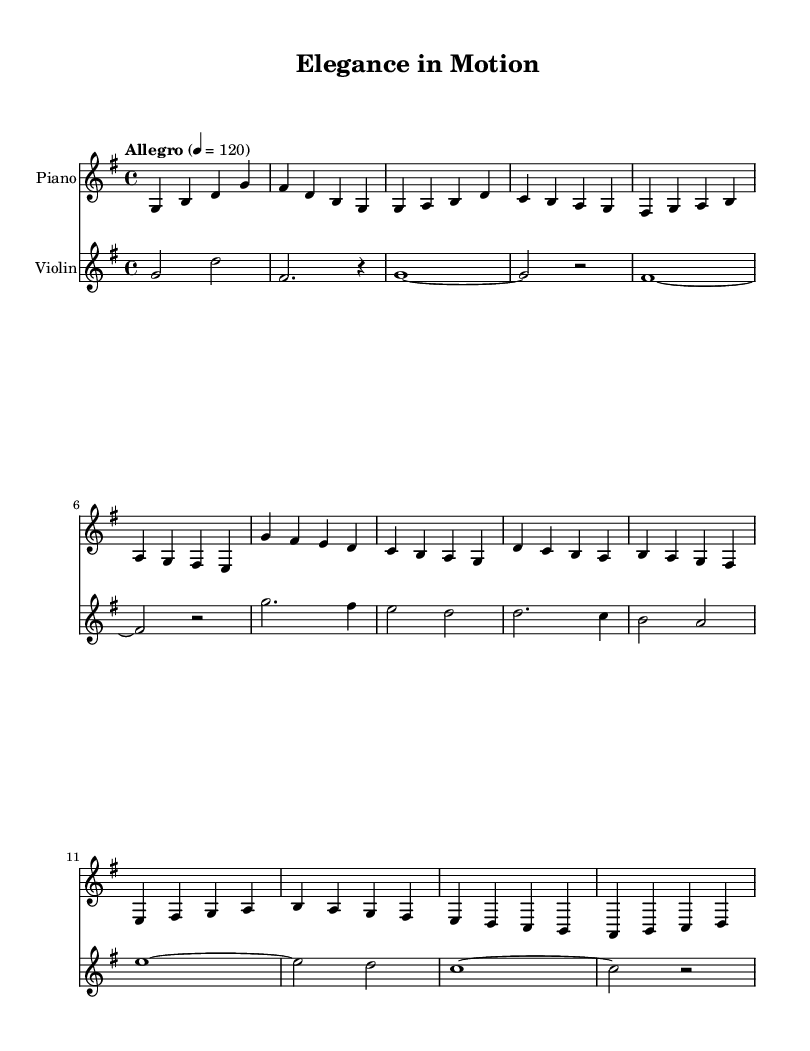What is the key signature of this music? The key signature indicates that this piece is in G major, which is represented by one sharp (F#). The sharp is found in the key signature area at the beginning of the staff.
Answer: G major What is the time signature of this piece? The time signature is shown as 4/4, which means there are four beats in each measure and the quarter note receives one beat. This can be seen at the beginning of the staff, right after the key signature.
Answer: 4/4 What is the tempo marking of this composition? The tempo marking states "Allegro" followed by "4 = 120", which indicates the piece should be played at a lively pace of 120 beats per minute. This is clearly written at the start of the score above the staff.
Answer: Allegro, 120 How many measures are there in the piano part? By counting the horizontal lines that represent measures in the piano staff, there are a total of 12 measures. This count reflects the sections of music combined into the staff.
Answer: 12 Which instrument plays a melody primarily in the lower range? The piano is clearly indicated as the instrument that plays notes lower in pitch as it starts from a lower octave, while the violin plays higher pitches. This can be determined by examining the clefs and the specific notes on the staff.
Answer: Piano Is there a rest present in the violin part? Yes, there is a whole note rest indicated in the second measure of the violin part, represented by a symbol that looks like a squiggly line. This can be located in the music by checking for silence within a measure.
Answer: Yes 